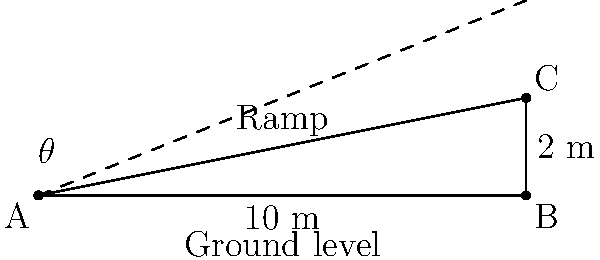As a rookie police officer inspecting a new community center, you notice a wheelchair ramp at the entrance. The ramp is 10 meters long and rises to a height of 2 meters. What is the angle $\theta$ of inclination of the ramp? Round your answer to the nearest degree. To find the angle of inclination $\theta$, we can use the trigonometric function sine. In a right-angled triangle:

$\sin(\theta) = \frac{\text{opposite}}{\text{hypotenuse}}$

1) The opposite side (rise) is 2 meters
2) The hypotenuse (length of the ramp) is 10 meters

Therefore:

$\sin(\theta) = \frac{2}{10} = 0.2$

To find $\theta$, we need to use the inverse sine function (arcsin):

$\theta = \arcsin(0.2)$

Using a calculator or trigonometric tables:

$\theta \approx 11.5372°$

Rounding to the nearest degree:

$\theta \approx 12°$
Answer: $12°$ 